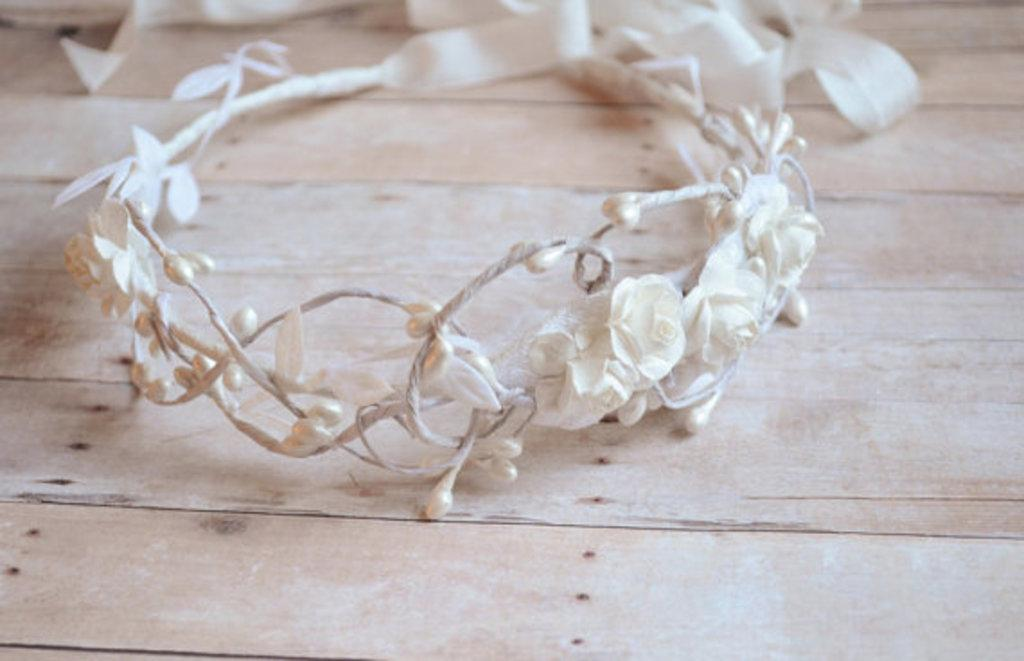What is the main object in the image? There is a table in the image. What is placed on the table? There is a tiara on the table. Can you see a tree in the image? There is no tree present in the image. Is someone reading a book on the table? There is no book or person reading in the image. 